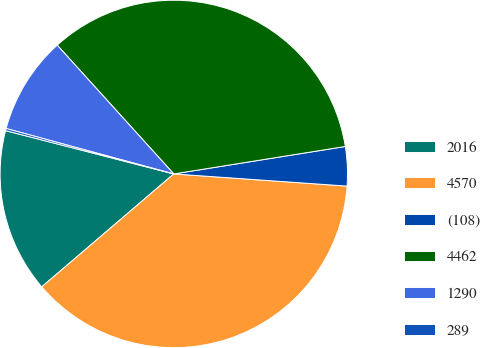<chart> <loc_0><loc_0><loc_500><loc_500><pie_chart><fcel>2016<fcel>4570<fcel>(108)<fcel>4462<fcel>1290<fcel>289<nl><fcel>15.27%<fcel>37.62%<fcel>3.64%<fcel>34.18%<fcel>9.08%<fcel>0.2%<nl></chart> 